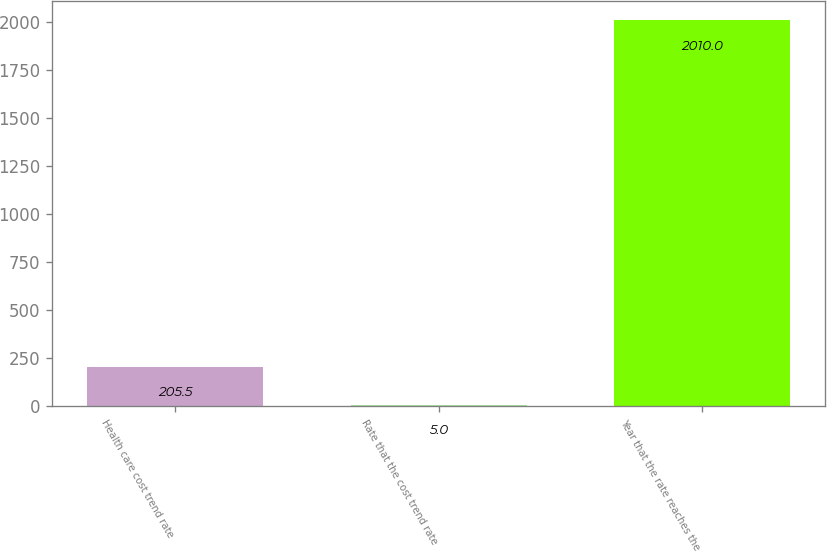Convert chart. <chart><loc_0><loc_0><loc_500><loc_500><bar_chart><fcel>Health care cost trend rate<fcel>Rate that the cost trend rate<fcel>Year that the rate reaches the<nl><fcel>205.5<fcel>5<fcel>2010<nl></chart> 